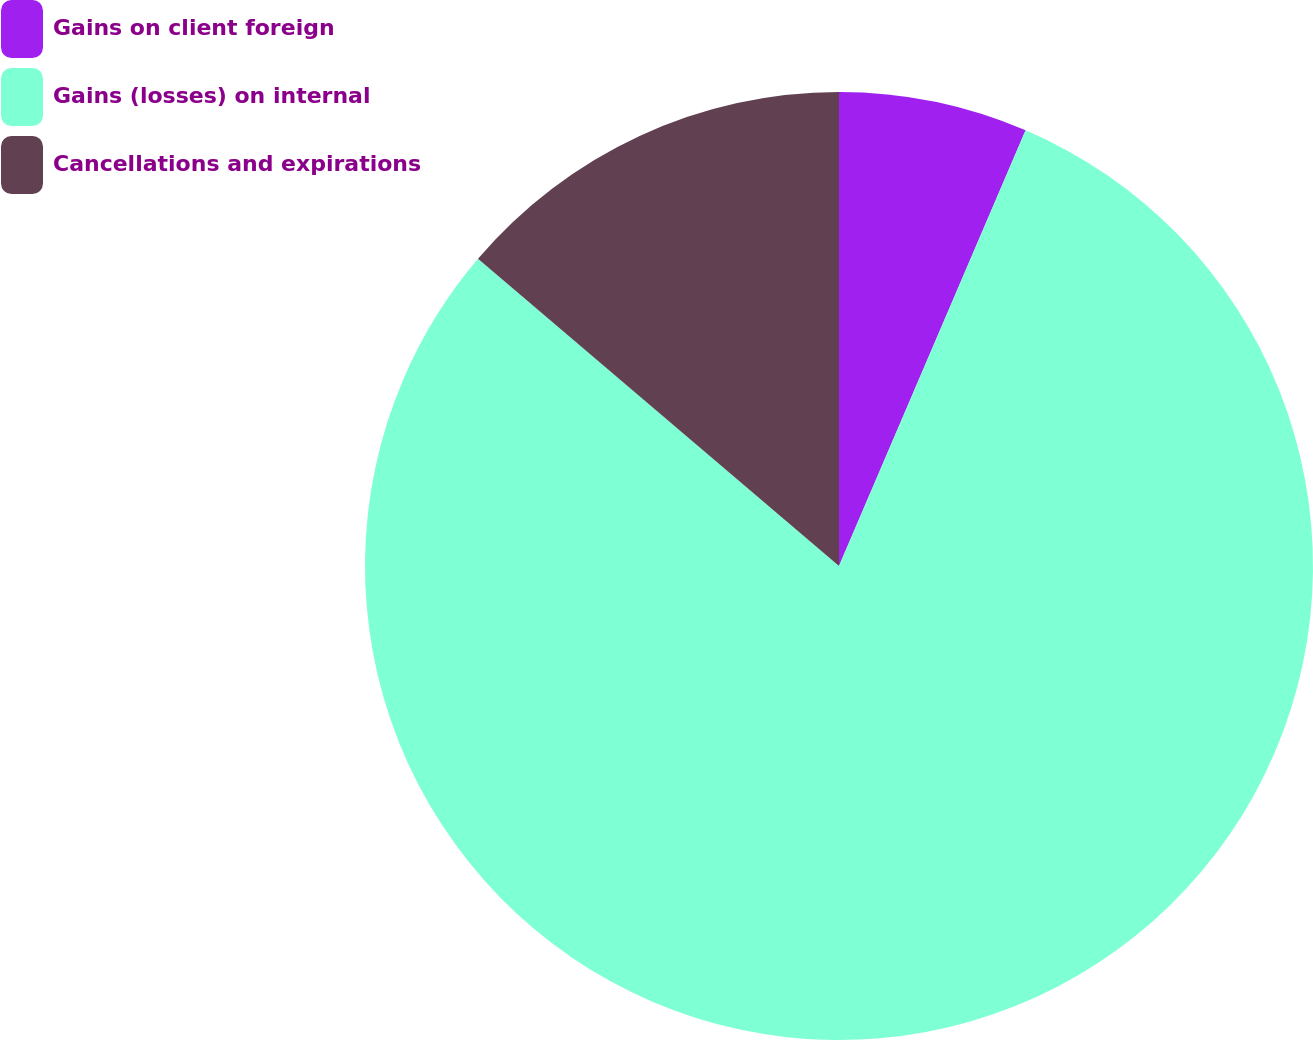<chart> <loc_0><loc_0><loc_500><loc_500><pie_chart><fcel>Gains on client foreign<fcel>Gains (losses) on internal<fcel>Cancellations and expirations<nl><fcel>6.44%<fcel>79.78%<fcel>13.78%<nl></chart> 